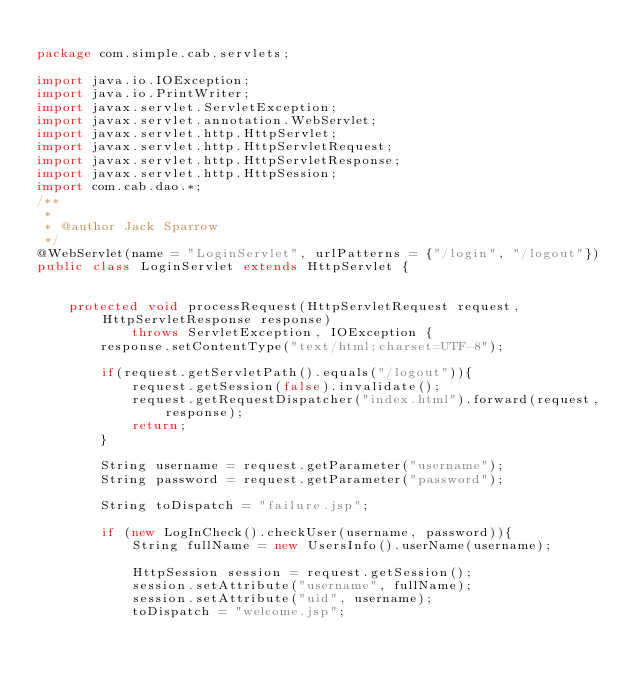<code> <loc_0><loc_0><loc_500><loc_500><_Java_>
package com.simple.cab.servlets;

import java.io.IOException;
import java.io.PrintWriter;
import javax.servlet.ServletException;
import javax.servlet.annotation.WebServlet;
import javax.servlet.http.HttpServlet;
import javax.servlet.http.HttpServletRequest;
import javax.servlet.http.HttpServletResponse;
import javax.servlet.http.HttpSession;
import com.cab.dao.*;
/**
 *
 * @author Jack Sparrow
 */
@WebServlet(name = "LoginServlet", urlPatterns = {"/login", "/logout"})
public class LoginServlet extends HttpServlet {

   
    protected void processRequest(HttpServletRequest request, HttpServletResponse response)
            throws ServletException, IOException {
        response.setContentType("text/html;charset=UTF-8");
        
        if(request.getServletPath().equals("/logout")){
            request.getSession(false).invalidate();
            request.getRequestDispatcher("index.html").forward(request, response);
            return;
        }
        
        String username = request.getParameter("username");
        String password = request.getParameter("password");

        String toDispatch = "failure.jsp";
        
        if (new LogInCheck().checkUser(username, password)){
            String fullName = new UsersInfo().userName(username);
            
            HttpSession session = request.getSession();            
            session.setAttribute("username", fullName);
            session.setAttribute("uid", username);
            toDispatch = "welcome.jsp";</code> 